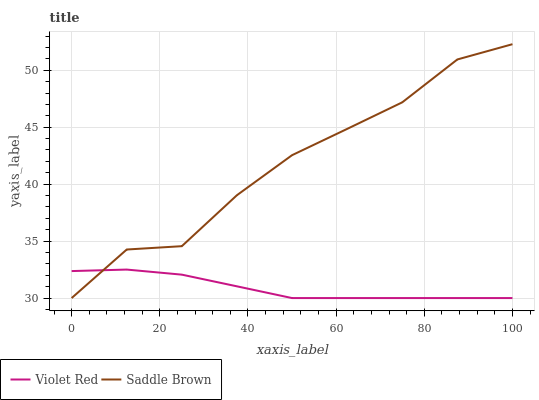Does Violet Red have the minimum area under the curve?
Answer yes or no. Yes. Does Saddle Brown have the maximum area under the curve?
Answer yes or no. Yes. Does Saddle Brown have the minimum area under the curve?
Answer yes or no. No. Is Violet Red the smoothest?
Answer yes or no. Yes. Is Saddle Brown the roughest?
Answer yes or no. Yes. Is Saddle Brown the smoothest?
Answer yes or no. No. Does Violet Red have the lowest value?
Answer yes or no. Yes. Does Saddle Brown have the highest value?
Answer yes or no. Yes. Does Violet Red intersect Saddle Brown?
Answer yes or no. Yes. Is Violet Red less than Saddle Brown?
Answer yes or no. No. Is Violet Red greater than Saddle Brown?
Answer yes or no. No. 